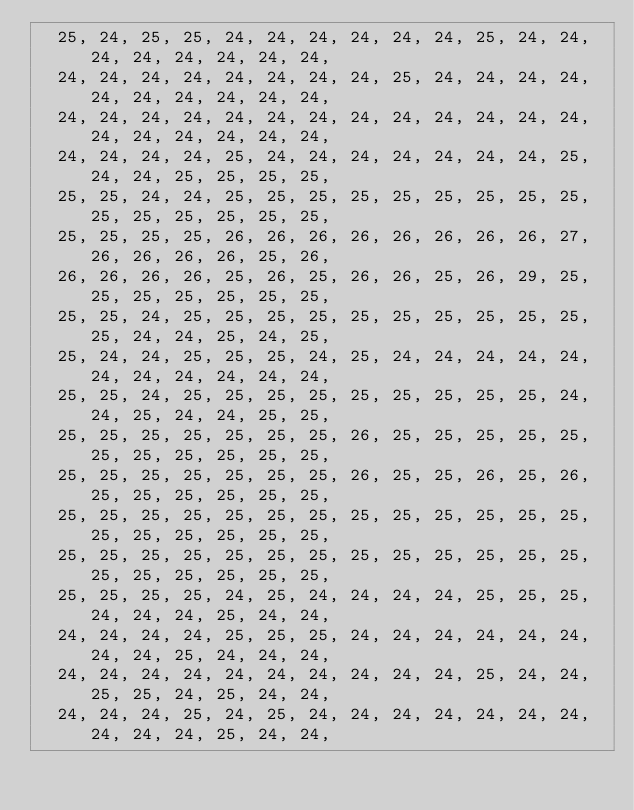<code> <loc_0><loc_0><loc_500><loc_500><_JavaScript_>  25, 24, 25, 25, 24, 24, 24, 24, 24, 24, 25, 24, 24, 24, 24, 24, 24, 24, 24,
  24, 24, 24, 24, 24, 24, 24, 24, 25, 24, 24, 24, 24, 24, 24, 24, 24, 24, 24,
  24, 24, 24, 24, 24, 24, 24, 24, 24, 24, 24, 24, 24, 24, 24, 24, 24, 24, 24,
  24, 24, 24, 24, 25, 24, 24, 24, 24, 24, 24, 24, 25, 24, 24, 25, 25, 25, 25,
  25, 25, 24, 24, 25, 25, 25, 25, 25, 25, 25, 25, 25, 25, 25, 25, 25, 25, 25,
  25, 25, 25, 25, 26, 26, 26, 26, 26, 26, 26, 26, 27, 26, 26, 26, 26, 25, 26,
  26, 26, 26, 26, 25, 26, 25, 26, 26, 25, 26, 29, 25, 25, 25, 25, 25, 25, 25,
  25, 25, 24, 25, 25, 25, 25, 25, 25, 25, 25, 25, 25, 25, 24, 24, 25, 24, 25,
  25, 24, 24, 25, 25, 25, 24, 25, 24, 24, 24, 24, 24, 24, 24, 24, 24, 24, 24,
  25, 25, 24, 25, 25, 25, 25, 25, 25, 25, 25, 25, 24, 24, 25, 24, 24, 25, 25,
  25, 25, 25, 25, 25, 25, 25, 26, 25, 25, 25, 25, 25, 25, 25, 25, 25, 25, 25,
  25, 25, 25, 25, 25, 25, 25, 26, 25, 25, 26, 25, 26, 25, 25, 25, 25, 25, 25,
  25, 25, 25, 25, 25, 25, 25, 25, 25, 25, 25, 25, 25, 25, 25, 25, 25, 25, 25,
  25, 25, 25, 25, 25, 25, 25, 25, 25, 25, 25, 25, 25, 25, 25, 25, 25, 25, 25,
  25, 25, 25, 25, 24, 25, 24, 24, 24, 24, 25, 25, 25, 24, 24, 24, 25, 24, 24,
  24, 24, 24, 24, 25, 25, 25, 24, 24, 24, 24, 24, 24, 24, 24, 25, 24, 24, 24,
  24, 24, 24, 24, 24, 24, 24, 24, 24, 24, 25, 24, 24, 25, 25, 24, 25, 24, 24,
  24, 24, 24, 25, 24, 25, 24, 24, 24, 24, 24, 24, 24, 24, 24, 24, 25, 24, 24,</code> 